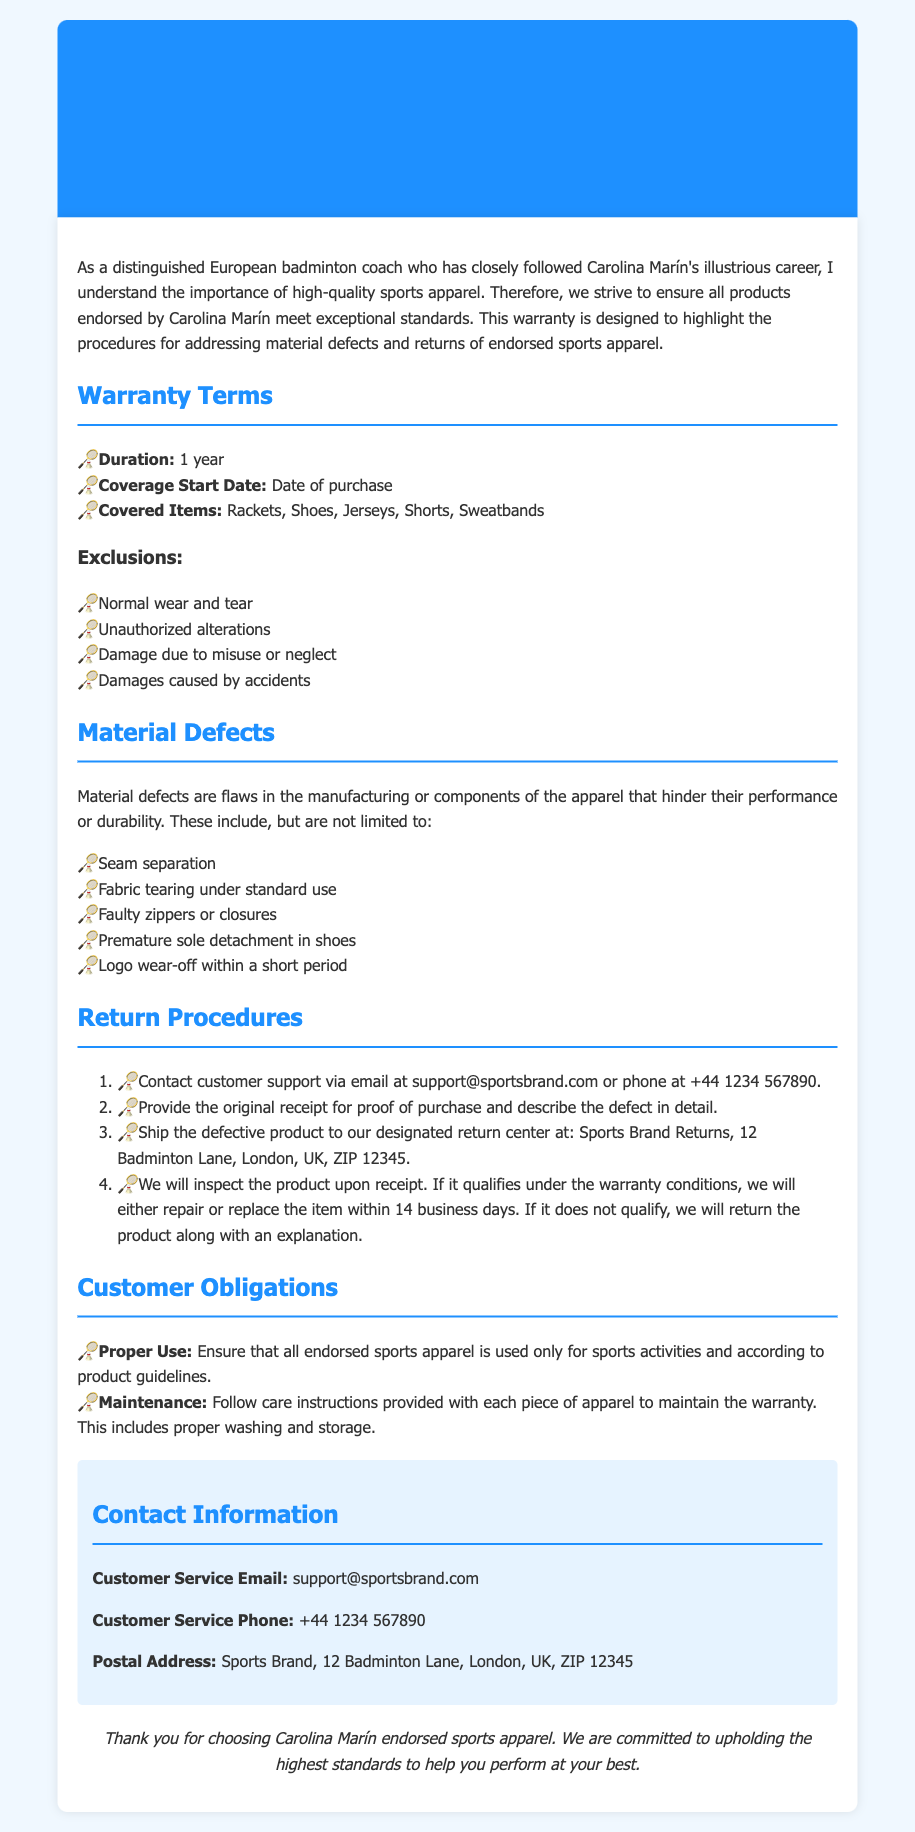What is the duration of the warranty? The duration of the warranty is specified in the document under the "Warranty Terms" section, which states it is 1 year.
Answer: 1 year When does the coverage start? The coverage start date is mentioned in the "Warranty Terms" section as the date of purchase.
Answer: Date of purchase Which items are covered under the warranty? The covered items are listed in the "Warranty Terms" section, specifying items like rackets, shoes, and jerseys.
Answer: Rackets, Shoes, Jerseys, Shorts, Sweatbands What are considered material defects? Material defects are described in the "Material Defects" section, detailing flaws that hinder performance or durability.
Answer: Seam separation, Fabric tearing under standard use, Faulty zippers or closures, Premature sole detachment in shoes, Logo wear-off within a short period How long will it take to process a warranty claim? The processing time for a warranty claim is mentioned in the "Return Procedures" section, indicating the inspection and response time.
Answer: 14 business days What should customers provide to initiate a return? The necessary information for initiating a return is outlined in the "Return Procedures" section, specifying what must be provided.
Answer: Original receipt and describe the defect What type of damages are excluded from the warranty? Exclusions are listed in the "Exclusions" section, detailing specific scenarios that are not covered.
Answer: Normal wear and tear, Unauthorized alterations, Damage due to misuse or neglect, Damages caused by accidents Where should defective products be sent for return? The return address is detailed in the "Return Procedures" section, indicating where customers should ship defective products.
Answer: Sports Brand Returns, 12 Badminton Lane, London, UK, ZIP 12345 